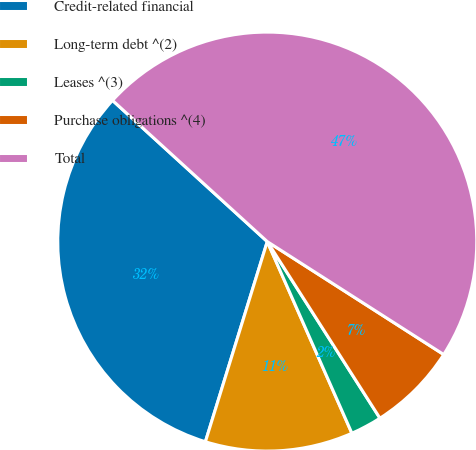<chart> <loc_0><loc_0><loc_500><loc_500><pie_chart><fcel>Credit-related financial<fcel>Long-term debt ^(2)<fcel>Leases ^(3)<fcel>Purchase obligations ^(4)<fcel>Total<nl><fcel>32.0%<fcel>11.39%<fcel>2.42%<fcel>6.9%<fcel>47.29%<nl></chart> 